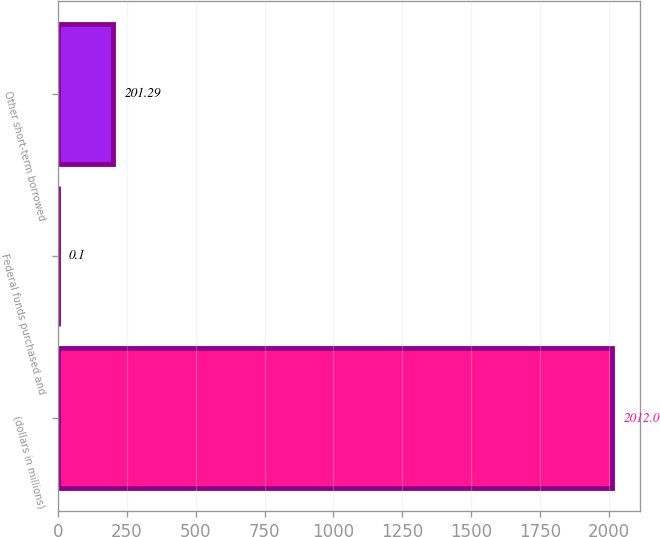Convert chart. <chart><loc_0><loc_0><loc_500><loc_500><bar_chart><fcel>(dollars in millions)<fcel>Federal funds purchased and<fcel>Other short-term borrowed<nl><fcel>2012<fcel>0.1<fcel>201.29<nl></chart> 